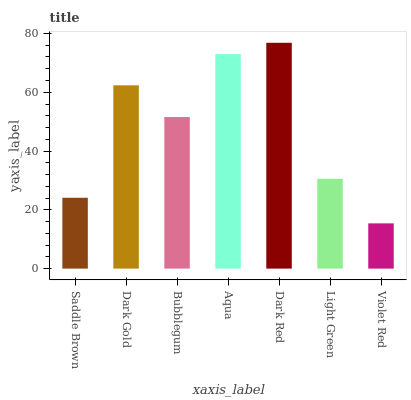Is Violet Red the minimum?
Answer yes or no. Yes. Is Dark Red the maximum?
Answer yes or no. Yes. Is Dark Gold the minimum?
Answer yes or no. No. Is Dark Gold the maximum?
Answer yes or no. No. Is Dark Gold greater than Saddle Brown?
Answer yes or no. Yes. Is Saddle Brown less than Dark Gold?
Answer yes or no. Yes. Is Saddle Brown greater than Dark Gold?
Answer yes or no. No. Is Dark Gold less than Saddle Brown?
Answer yes or no. No. Is Bubblegum the high median?
Answer yes or no. Yes. Is Bubblegum the low median?
Answer yes or no. Yes. Is Dark Red the high median?
Answer yes or no. No. Is Light Green the low median?
Answer yes or no. No. 